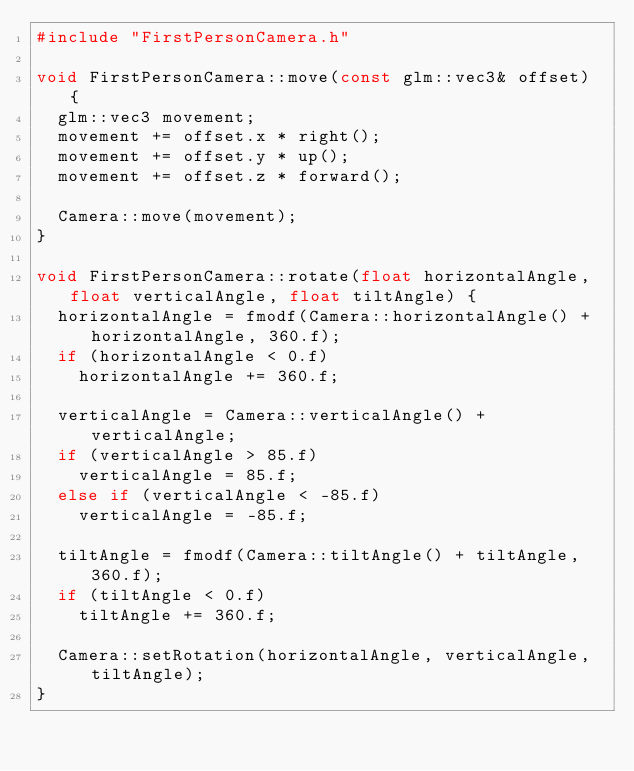<code> <loc_0><loc_0><loc_500><loc_500><_C++_>#include "FirstPersonCamera.h"

void FirstPersonCamera::move(const glm::vec3& offset) {
	glm::vec3 movement;
	movement += offset.x * right();
	movement += offset.y * up();
	movement += offset.z * forward();

	Camera::move(movement);
}

void FirstPersonCamera::rotate(float horizontalAngle, float verticalAngle, float tiltAngle) {
	horizontalAngle = fmodf(Camera::horizontalAngle() + horizontalAngle, 360.f);
	if (horizontalAngle < 0.f)
		horizontalAngle += 360.f;

	verticalAngle = Camera::verticalAngle() + verticalAngle;
	if (verticalAngle > 85.f)
		verticalAngle = 85.f;
	else if (verticalAngle < -85.f)
		verticalAngle = -85.f;

	tiltAngle = fmodf(Camera::tiltAngle() + tiltAngle, 360.f);
	if (tiltAngle < 0.f)
		tiltAngle += 360.f;

	Camera::setRotation(horizontalAngle, verticalAngle, tiltAngle);
}</code> 